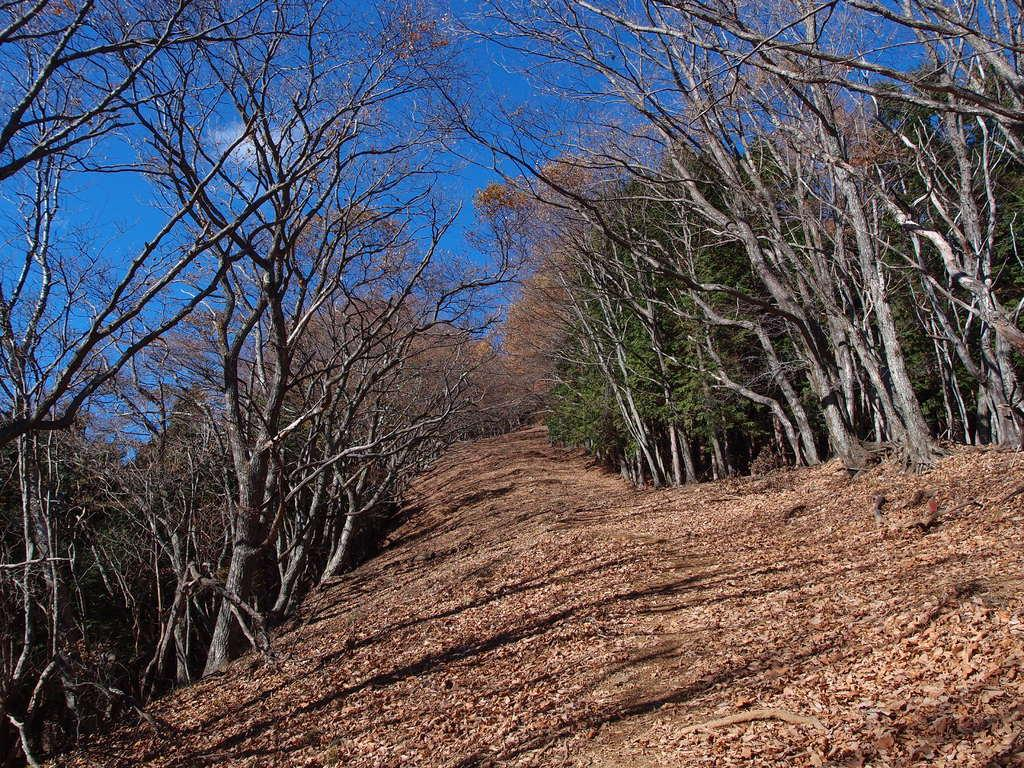What is on the ground in the image? There are dried leaves on the ground in the image. What type of vegetation can be seen in the image? There are many trees visible in the image. What color is the sky in the background of the image? The blue sky is visible in the background of the image. What condition is the glass in the image? There is no glass present in the image; it only features dried leaves, trees, and the blue sky. 